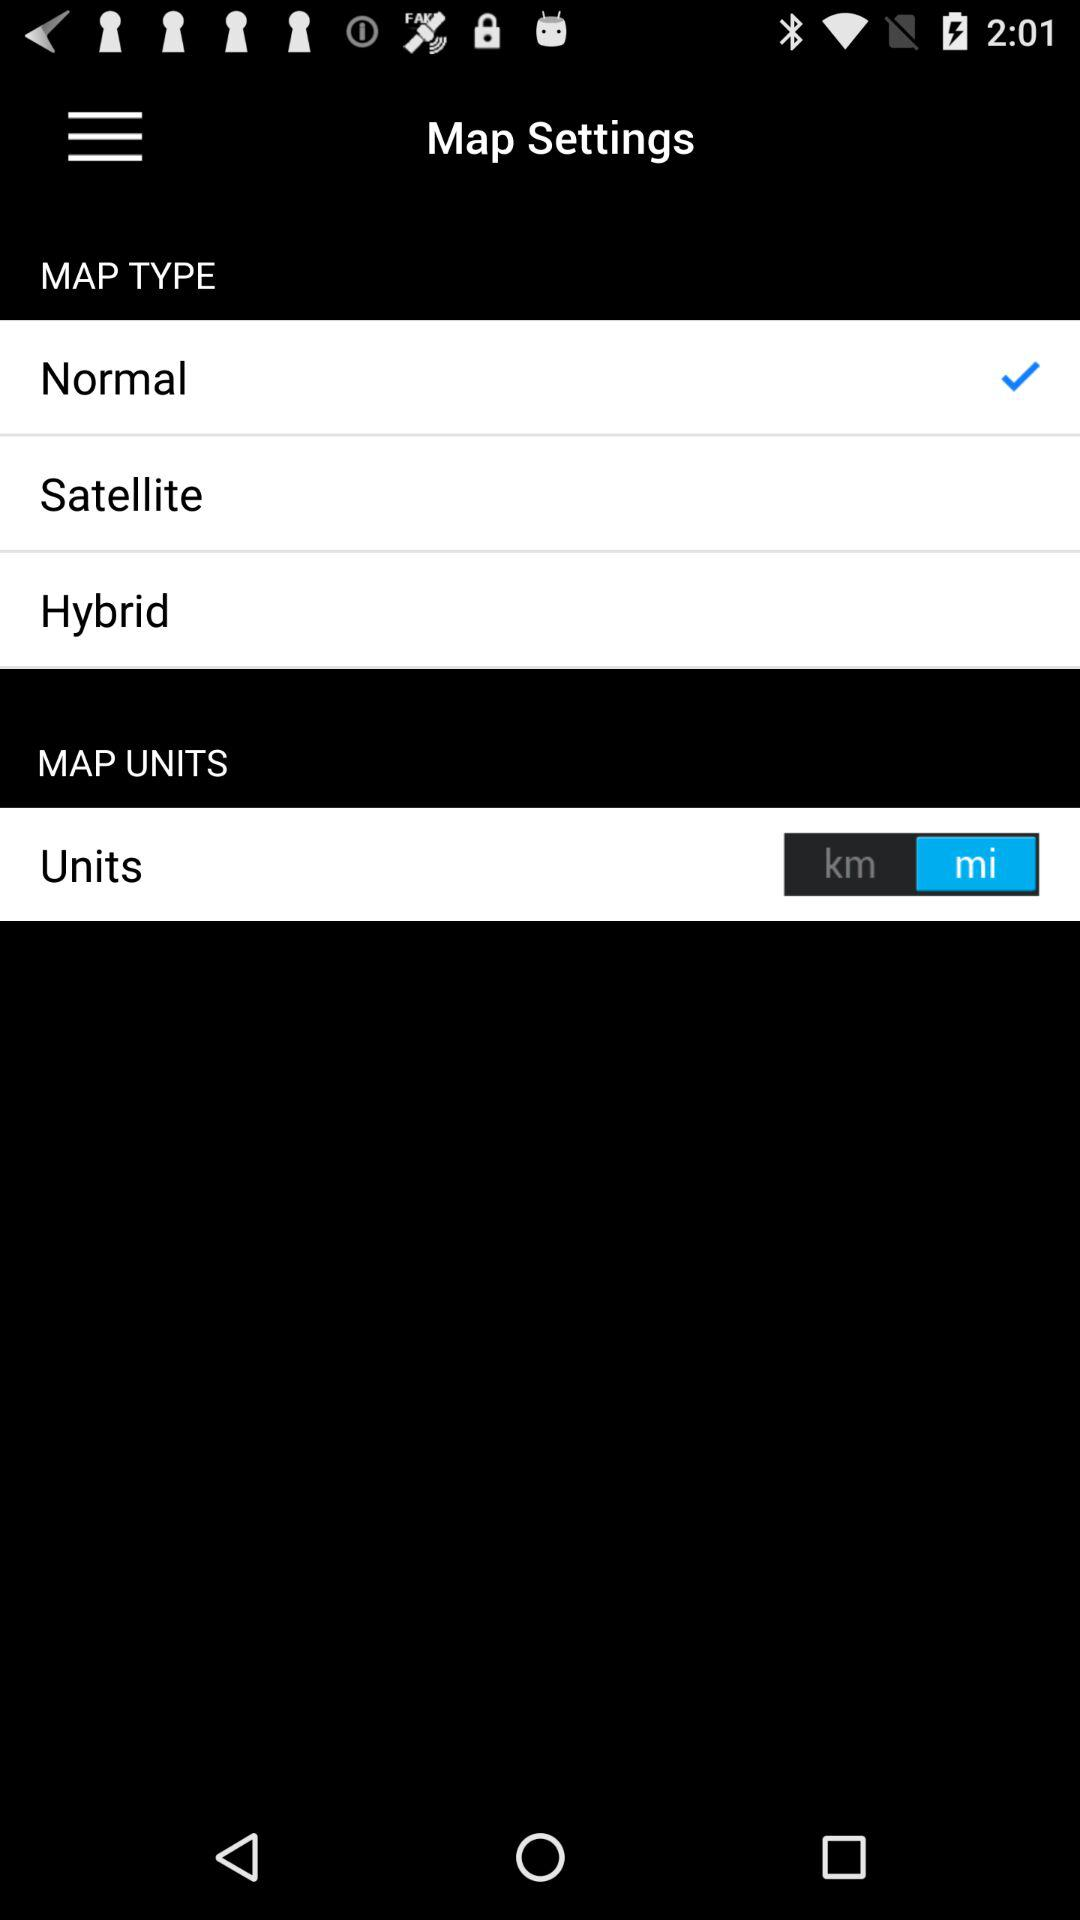How many units are available?
Answer the question using a single word or phrase. 2 